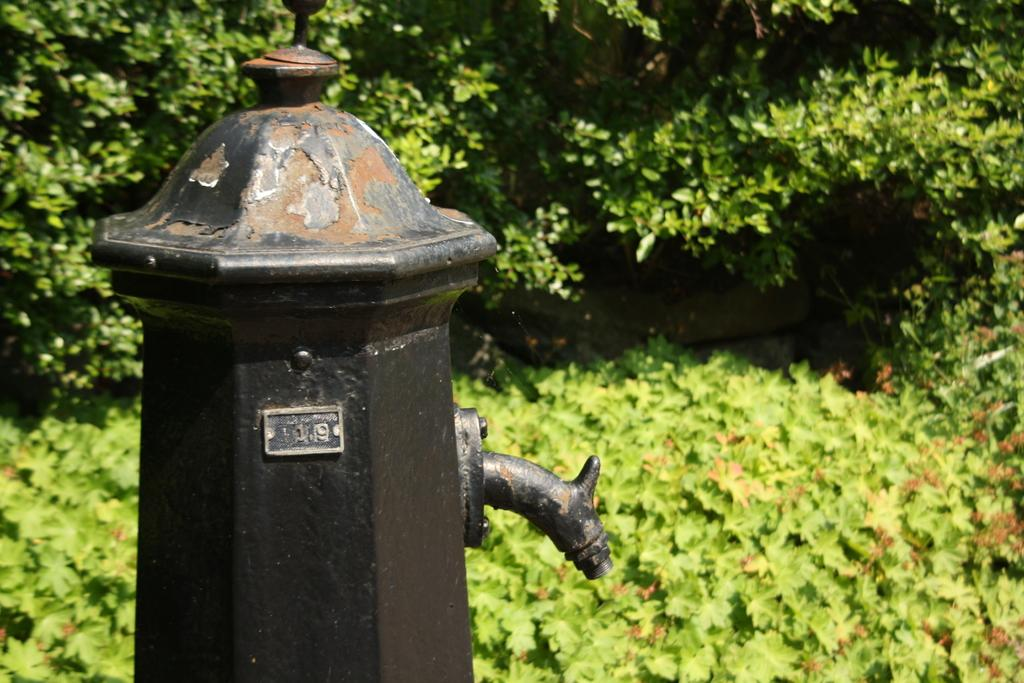What is the main object in the image? There is a black color pole with a pipe in the image. What can be seen in the background of the image? There are plants and trees in the background of the image. How many hours does the pipe in the image last? The image does not provide information about the duration or lifespan of the pipe, so it is not possible to answer this question. 